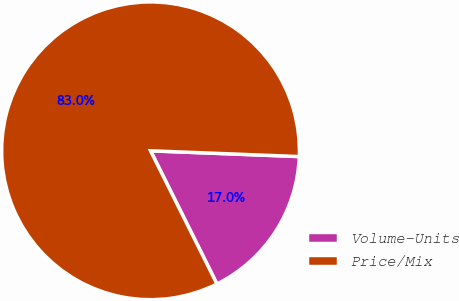<chart> <loc_0><loc_0><loc_500><loc_500><pie_chart><fcel>Volume-Units<fcel>Price/Mix<nl><fcel>17.02%<fcel>82.98%<nl></chart> 